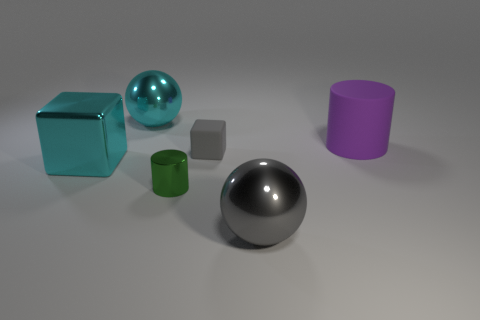Does the rubber thing that is on the left side of the big rubber object have the same size as the cyan metallic object that is in front of the big purple cylinder?
Give a very brief answer. No. There is a sphere behind the cyan shiny object left of the large metal thing behind the purple matte object; how big is it?
Provide a short and direct response. Large. What is the shape of the matte object that is right of the big sphere in front of the purple cylinder?
Your answer should be very brief. Cylinder. Does the big metal sphere that is to the right of the small green metal cylinder have the same color as the matte cylinder?
Keep it short and to the point. No. There is a large object that is both behind the cyan block and to the left of the large purple object; what color is it?
Offer a terse response. Cyan. Is there another purple cylinder that has the same material as the purple cylinder?
Offer a very short reply. No. The green shiny object is what size?
Your answer should be compact. Small. What is the size of the metal object to the right of the cylinder in front of the matte cylinder?
Ensure brevity in your answer.  Large. There is another object that is the same shape as the large gray thing; what is its material?
Your answer should be very brief. Metal. What number of purple cylinders are there?
Offer a very short reply. 1. 